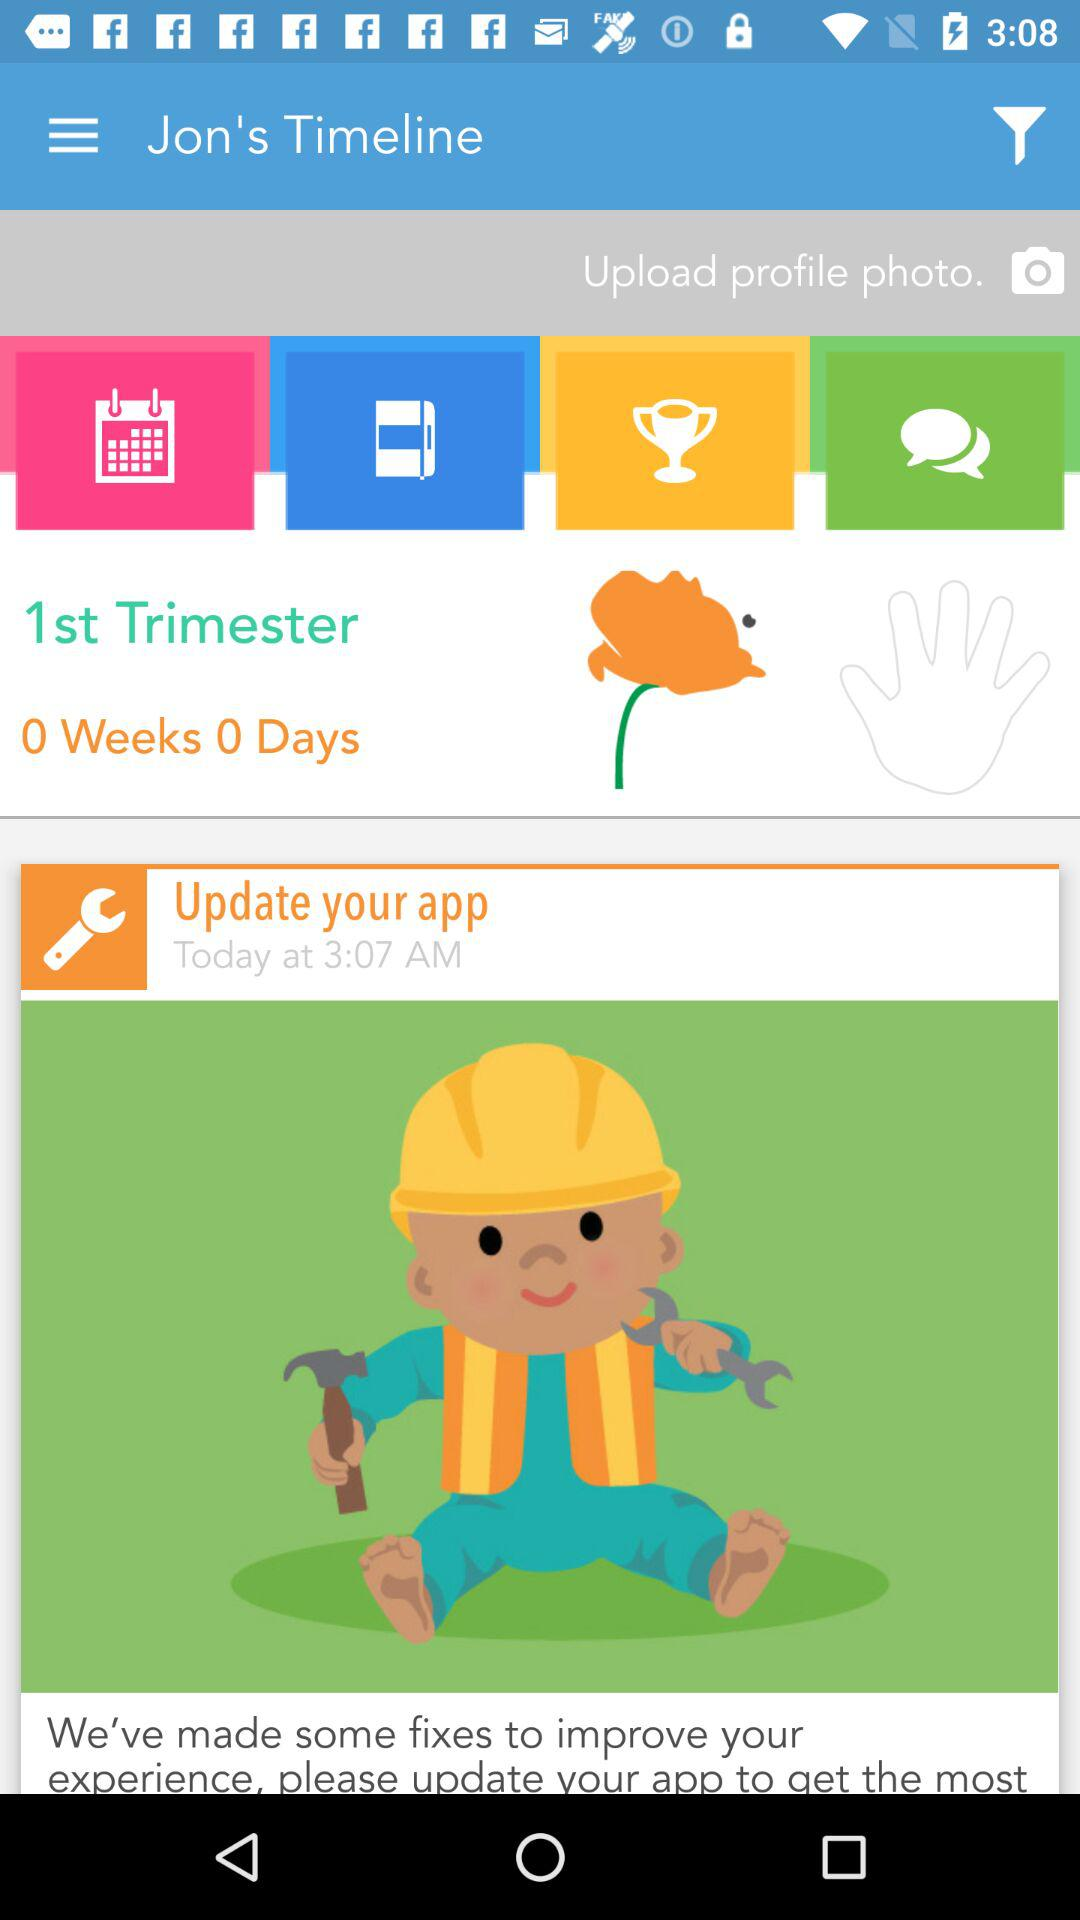What trimester does it shows? It shows 1st trimester. 